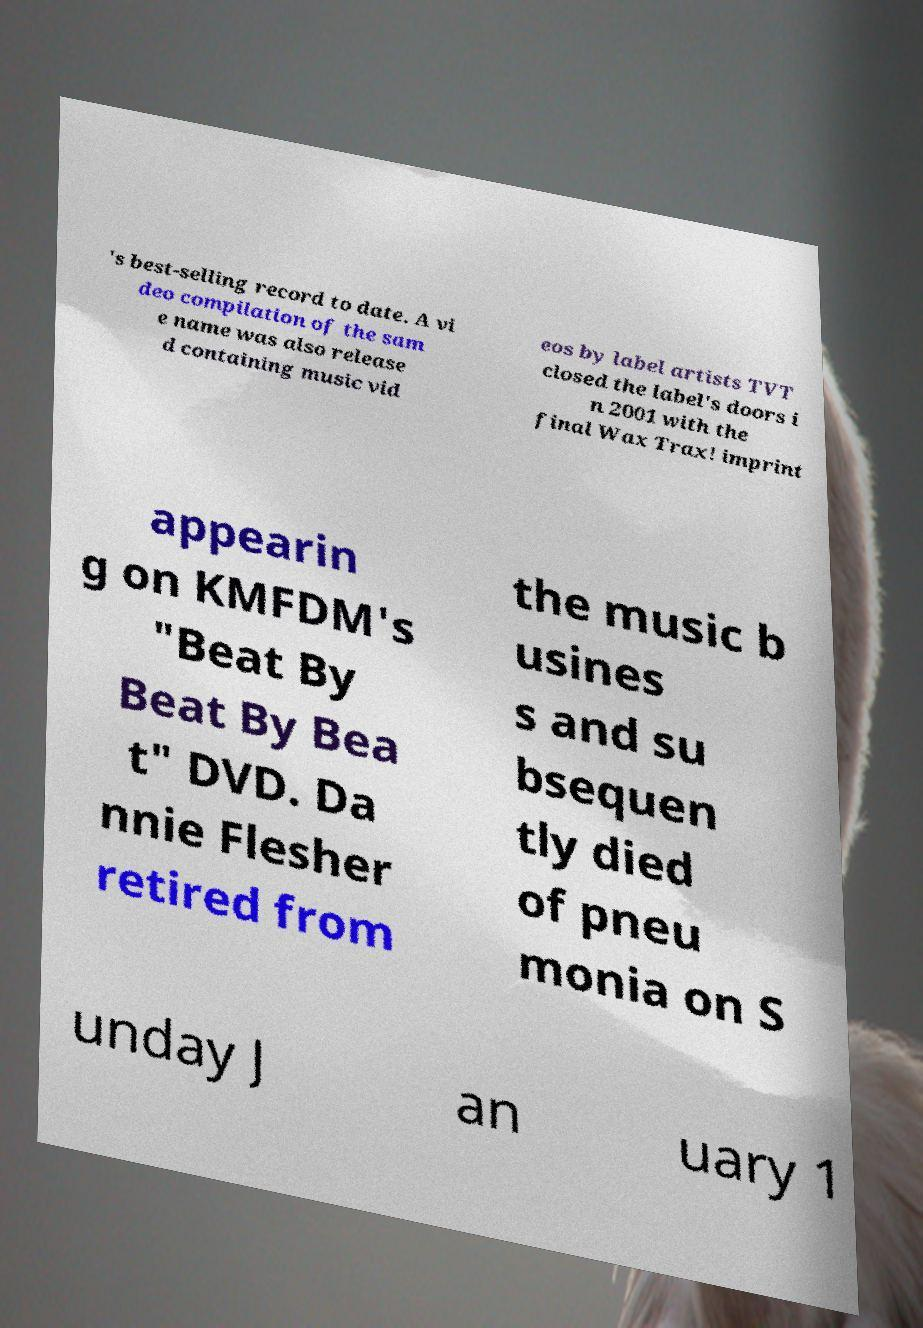What messages or text are displayed in this image? I need them in a readable, typed format. 's best-selling record to date. A vi deo compilation of the sam e name was also release d containing music vid eos by label artists TVT closed the label's doors i n 2001 with the final Wax Trax! imprint appearin g on KMFDM's "Beat By Beat By Bea t" DVD. Da nnie Flesher retired from the music b usines s and su bsequen tly died of pneu monia on S unday J an uary 1 